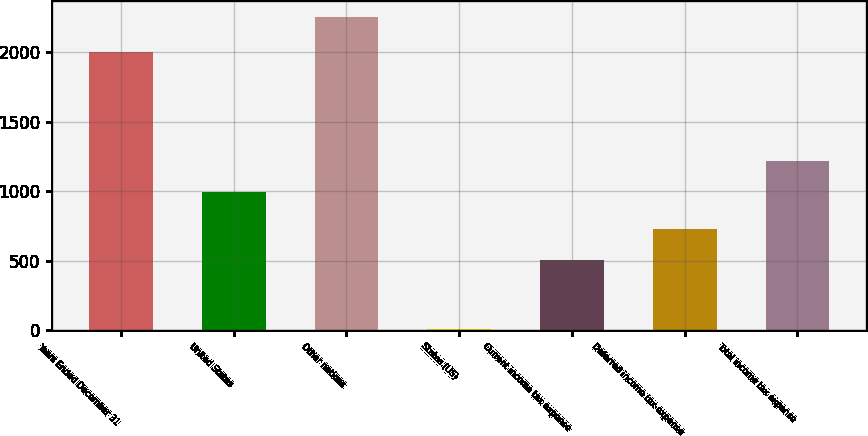Convert chart. <chart><loc_0><loc_0><loc_500><loc_500><bar_chart><fcel>Years Ended December 31<fcel>United States<fcel>Other nations<fcel>States (US)<fcel>Current income tax expense<fcel>Deferred income tax expense<fcel>Total income tax expense<nl><fcel>2004<fcel>994<fcel>2258<fcel>6<fcel>506<fcel>731.2<fcel>1219.2<nl></chart> 